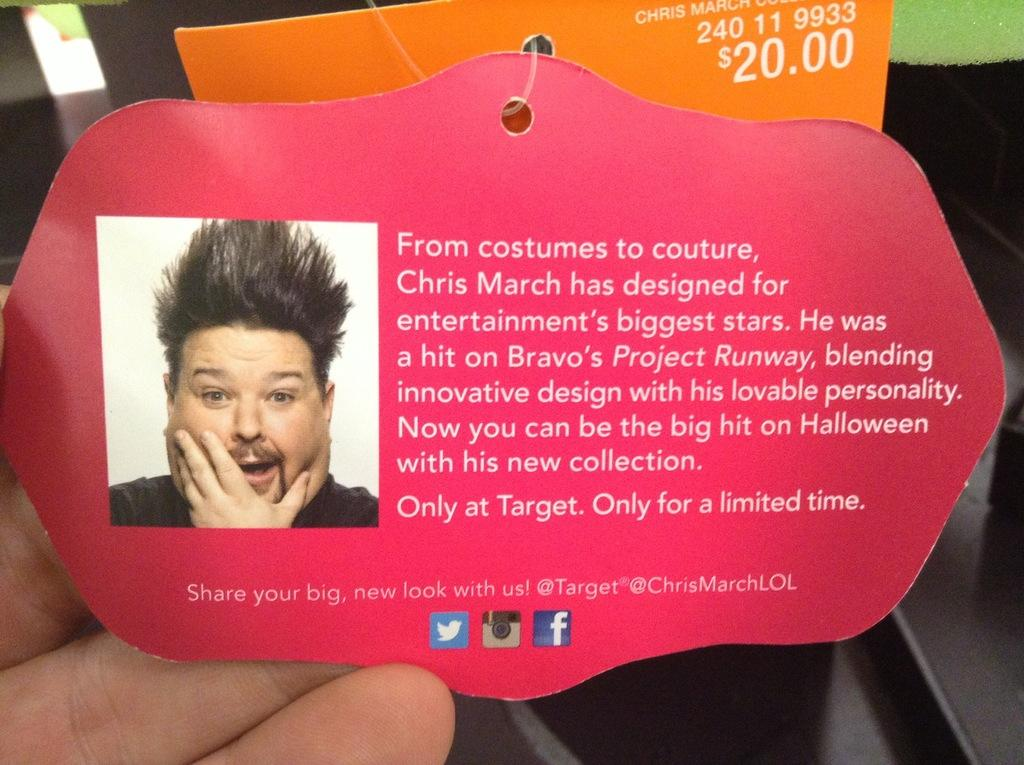What can be seen in the image that is related to the human body? There are fingers visible in the image. What else can be seen in the image besides the fingers? There are two tags with text in the image. Can you describe one of the tags in more detail? One of the tags has a picture of a person on it. How does the image convey a message of wealth and hate through the use of wine? The image does not convey any messages related to wealth, hate, or wine, as these topics are not present in the image. 